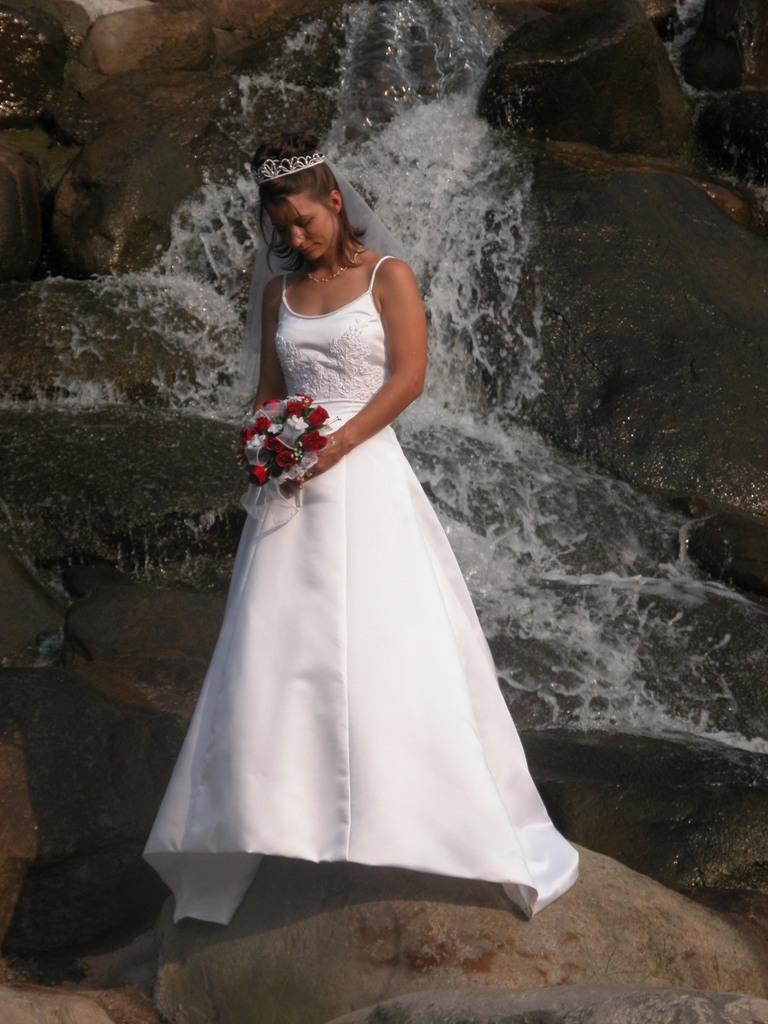What is present in the image? There is a person in the image. What is the person holding in the image? The person is holding an object. What can be seen in the background of the image? There is water and rocks visible in the background of the image. Where is the lunchroom located in the image? There is no lunchroom present in the image. How is the person measuring the rocks in the image? The person is not measuring the rocks in the image; they are simply holding an object. Is the person sleeping in the image? There is no indication that the person is sleeping in the image. 